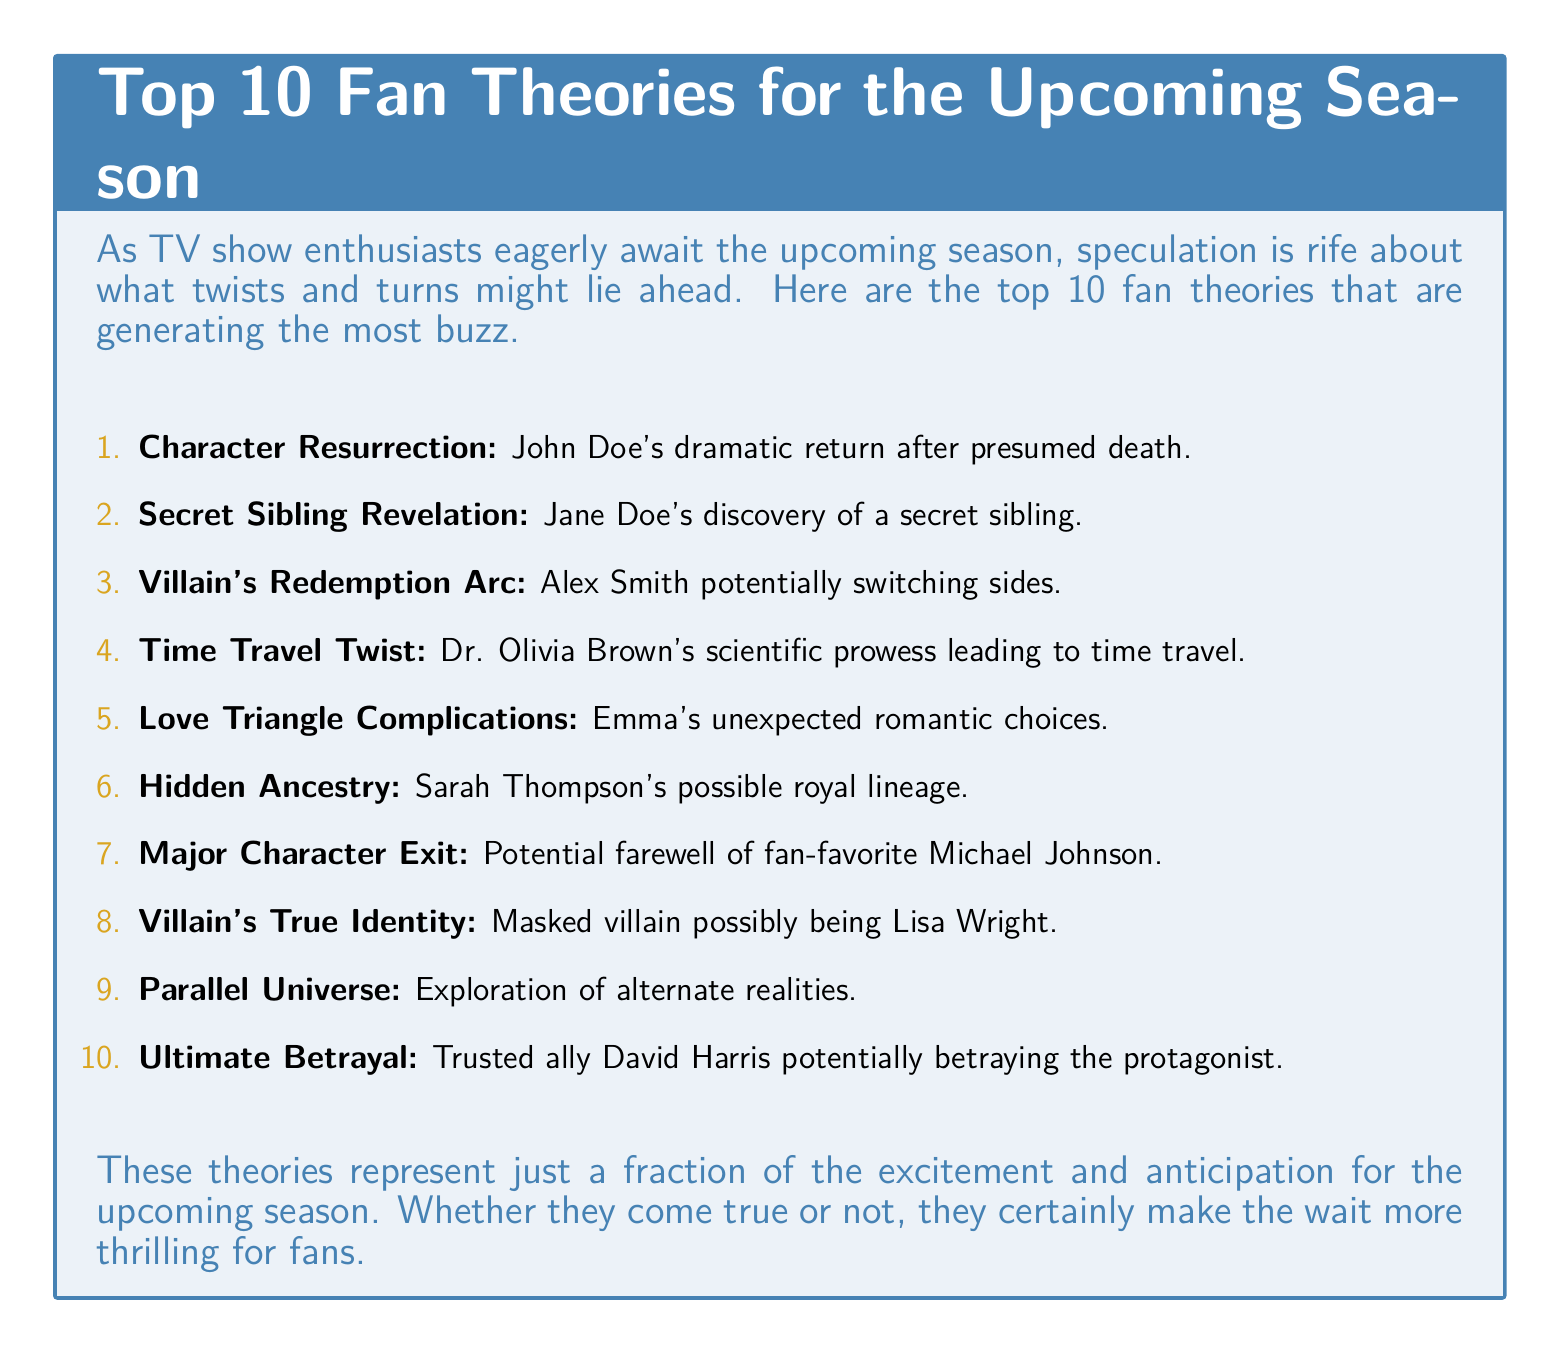What is the first fan theory listed? The document begins with the first fan theory about John Doe's return after presumed death.
Answer: Character Resurrection How many fan theories are presented? The document features a total of 10 fan theories listed numerically from 1 to 10.
Answer: 10 Who is the potential masked villain? According to the document, there is speculation that the masked villain may be Lisa Wright.
Answer: Lisa Wright What is the speculated situation for Michael Johnson? The document mentions that fan-favorite Michael Johnson may have a potential farewell in the upcoming season.
Answer: Major Character Exit Which character might discover a secret sibling? The document suggests that Jane Doe's character might find out about a secret sibling.
Answer: Jane Doe What is the theory involving Dr. Olivia Brown? The document discusses a theory in which Dr. Olivia Brown is potentially leading to a time travel scenario.
Answer: Time Travel Twist What complication might Emma face in her romantic life? The document indicates that Emma may encounter unexpected romantic choices, creating complications.
Answer: Love Triangle Complications What potential narrative could involve David Harris? The document raises the possibility of David Harris betraying the protagonist, indicating a narrative twist.
Answer: Ultimate Betrayal 